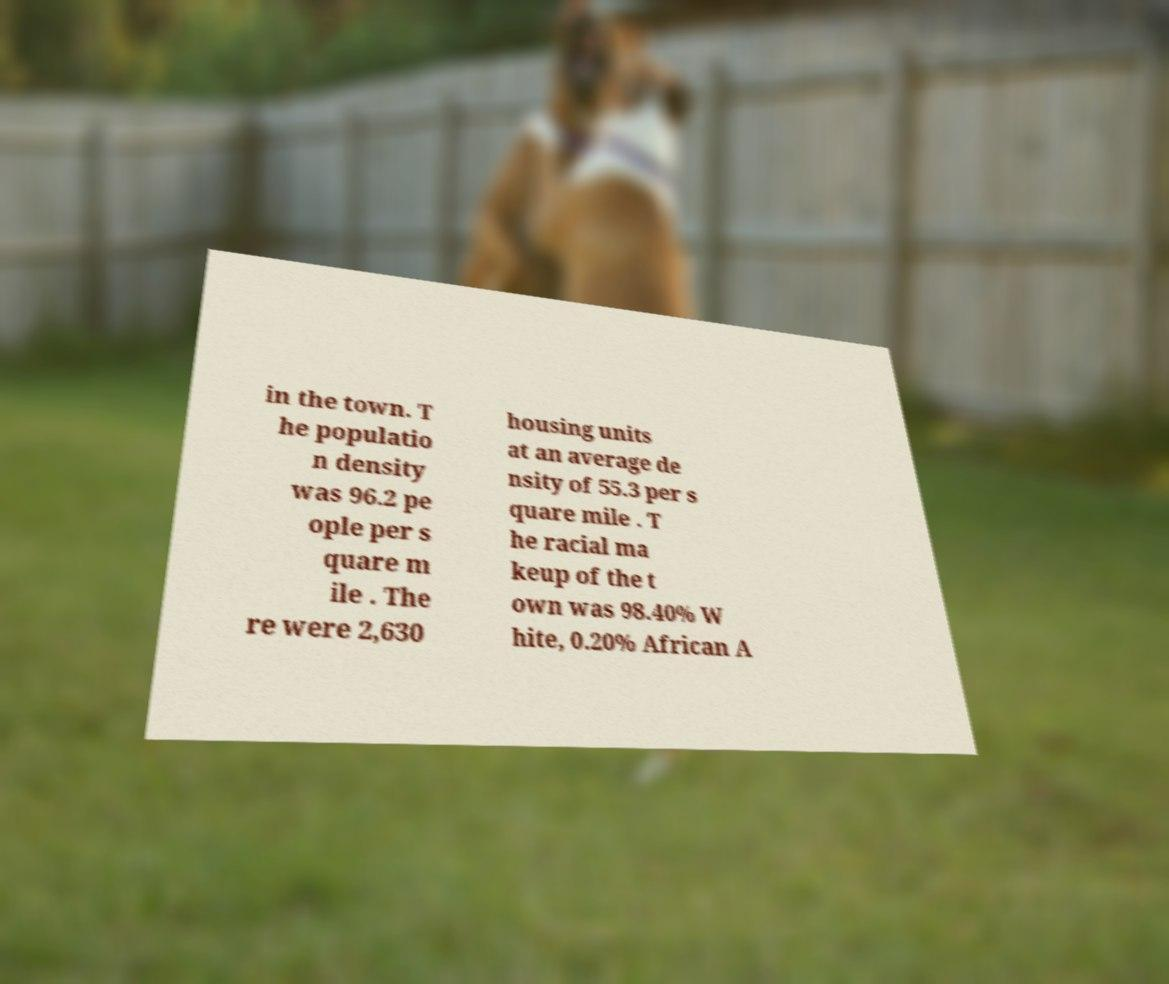Could you assist in decoding the text presented in this image and type it out clearly? in the town. T he populatio n density was 96.2 pe ople per s quare m ile . The re were 2,630 housing units at an average de nsity of 55.3 per s quare mile . T he racial ma keup of the t own was 98.40% W hite, 0.20% African A 